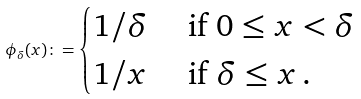<formula> <loc_0><loc_0><loc_500><loc_500>\phi _ { \delta } ( x ) \colon = \begin{cases} 1 / \delta & \text { if } 0 \leq x < \delta \\ 1 / x & \text { if } \delta \leq x \, . \end{cases}</formula> 